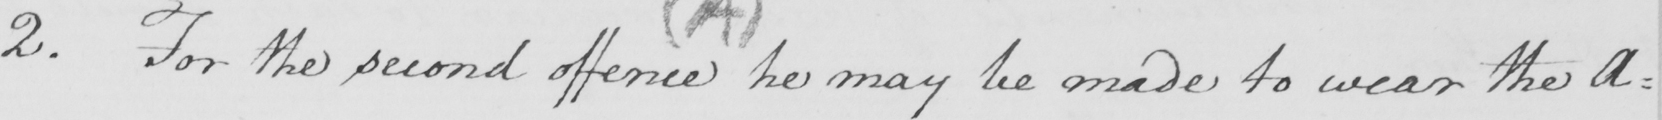Transcribe the text shown in this historical manuscript line. 2 . For the second offence  he may be made to wear the A= 